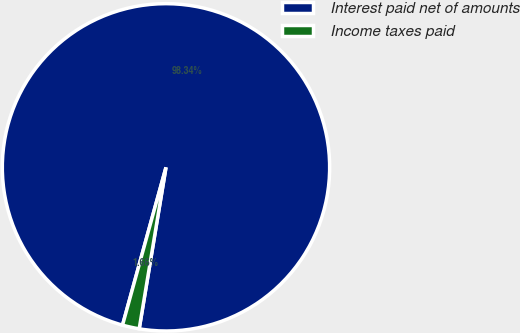Convert chart to OTSL. <chart><loc_0><loc_0><loc_500><loc_500><pie_chart><fcel>Interest paid net of amounts<fcel>Income taxes paid<nl><fcel>98.34%<fcel>1.66%<nl></chart> 